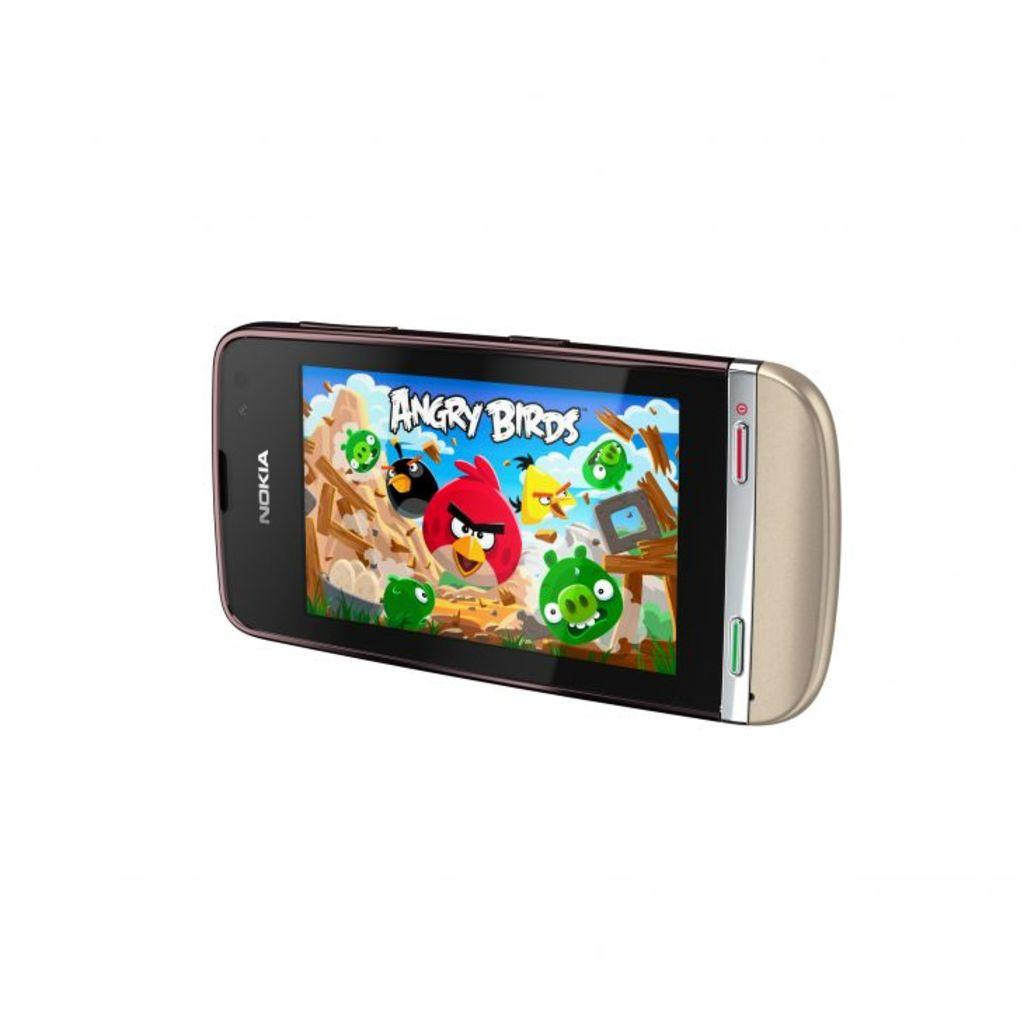<image>
Present a compact description of the photo's key features. A Nokia brand phone with the game Angry Birds on the screen. 